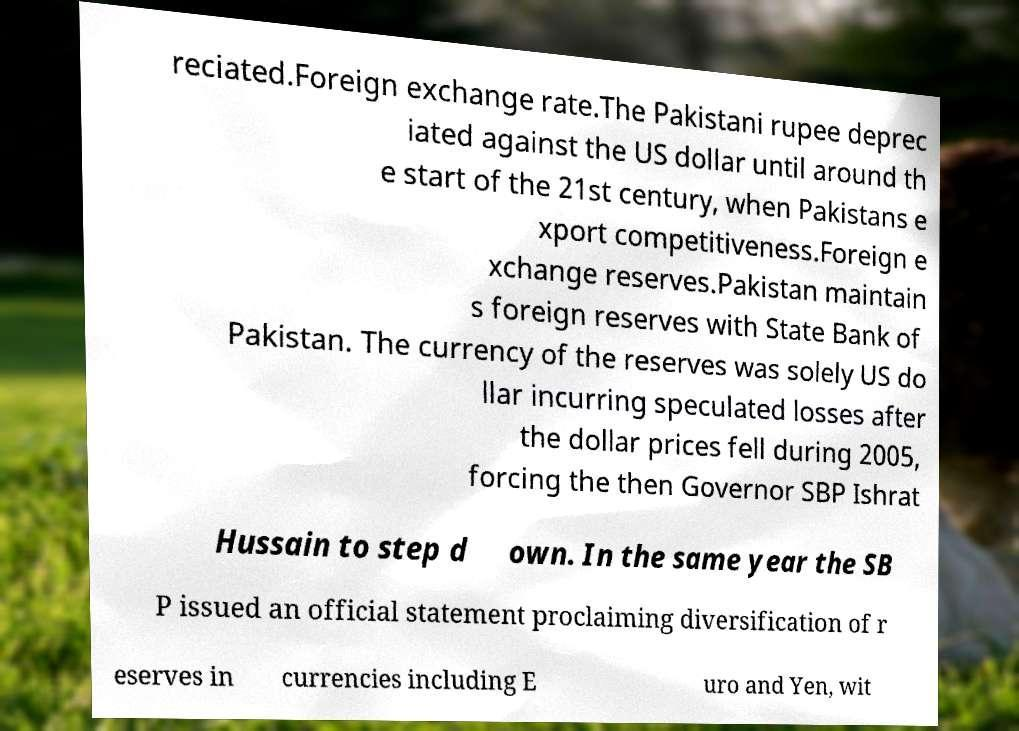What messages or text are displayed in this image? I need them in a readable, typed format. reciated.Foreign exchange rate.The Pakistani rupee deprec iated against the US dollar until around th e start of the 21st century, when Pakistans e xport competitiveness.Foreign e xchange reserves.Pakistan maintain s foreign reserves with State Bank of Pakistan. The currency of the reserves was solely US do llar incurring speculated losses after the dollar prices fell during 2005, forcing the then Governor SBP Ishrat Hussain to step d own. In the same year the SB P issued an official statement proclaiming diversification of r eserves in currencies including E uro and Yen, wit 